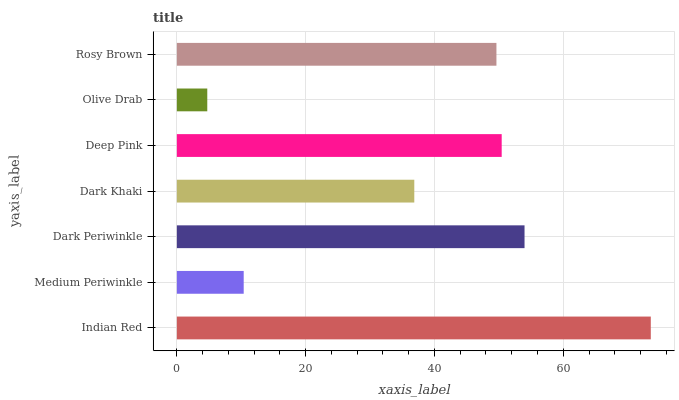Is Olive Drab the minimum?
Answer yes or no. Yes. Is Indian Red the maximum?
Answer yes or no. Yes. Is Medium Periwinkle the minimum?
Answer yes or no. No. Is Medium Periwinkle the maximum?
Answer yes or no. No. Is Indian Red greater than Medium Periwinkle?
Answer yes or no. Yes. Is Medium Periwinkle less than Indian Red?
Answer yes or no. Yes. Is Medium Periwinkle greater than Indian Red?
Answer yes or no. No. Is Indian Red less than Medium Periwinkle?
Answer yes or no. No. Is Rosy Brown the high median?
Answer yes or no. Yes. Is Rosy Brown the low median?
Answer yes or no. Yes. Is Dark Khaki the high median?
Answer yes or no. No. Is Dark Khaki the low median?
Answer yes or no. No. 